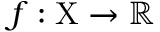Convert formula to latex. <formula><loc_0><loc_0><loc_500><loc_500>f \colon X \to \mathbb { R }</formula> 